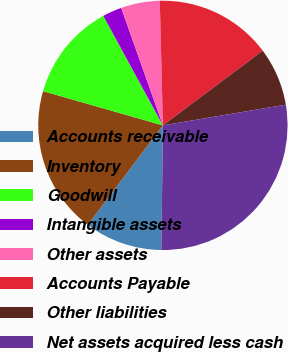Convert chart to OTSL. <chart><loc_0><loc_0><loc_500><loc_500><pie_chart><fcel>Accounts receivable<fcel>Inventory<fcel>Goodwill<fcel>Intangible assets<fcel>Other assets<fcel>Accounts Payable<fcel>Other liabilities<fcel>Net assets acquired less cash<nl><fcel>10.1%<fcel>19.13%<fcel>12.64%<fcel>2.5%<fcel>5.03%<fcel>15.17%<fcel>7.57%<fcel>27.85%<nl></chart> 